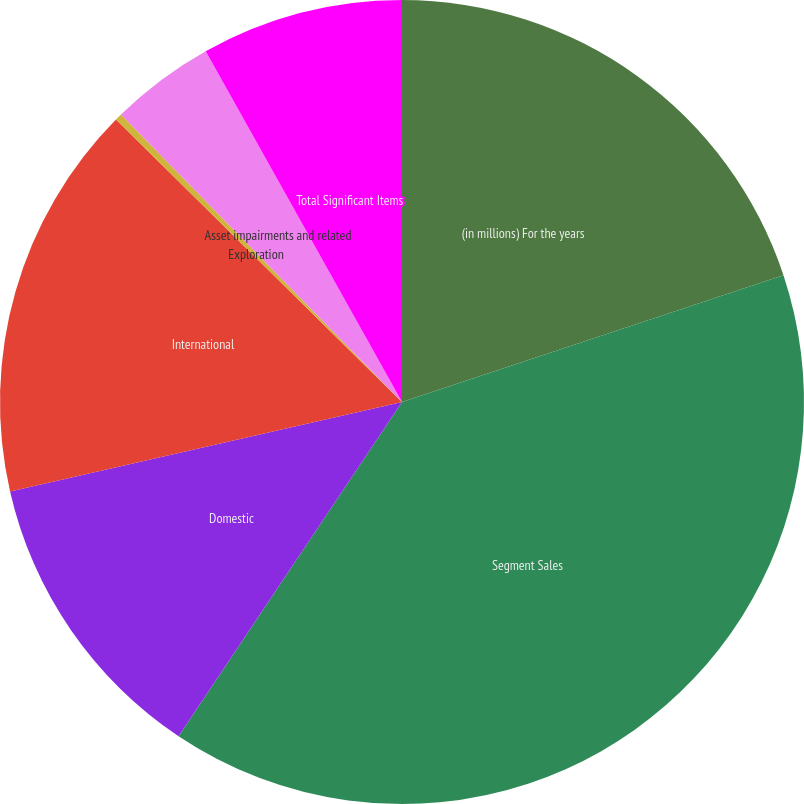Convert chart. <chart><loc_0><loc_0><loc_500><loc_500><pie_chart><fcel>(in millions) For the years<fcel>Segment Sales<fcel>Domestic<fcel>International<fcel>Exploration<fcel>Asset impairments and related<fcel>Total Significant Items<nl><fcel>19.89%<fcel>39.49%<fcel>12.05%<fcel>15.97%<fcel>0.28%<fcel>4.2%<fcel>8.12%<nl></chart> 